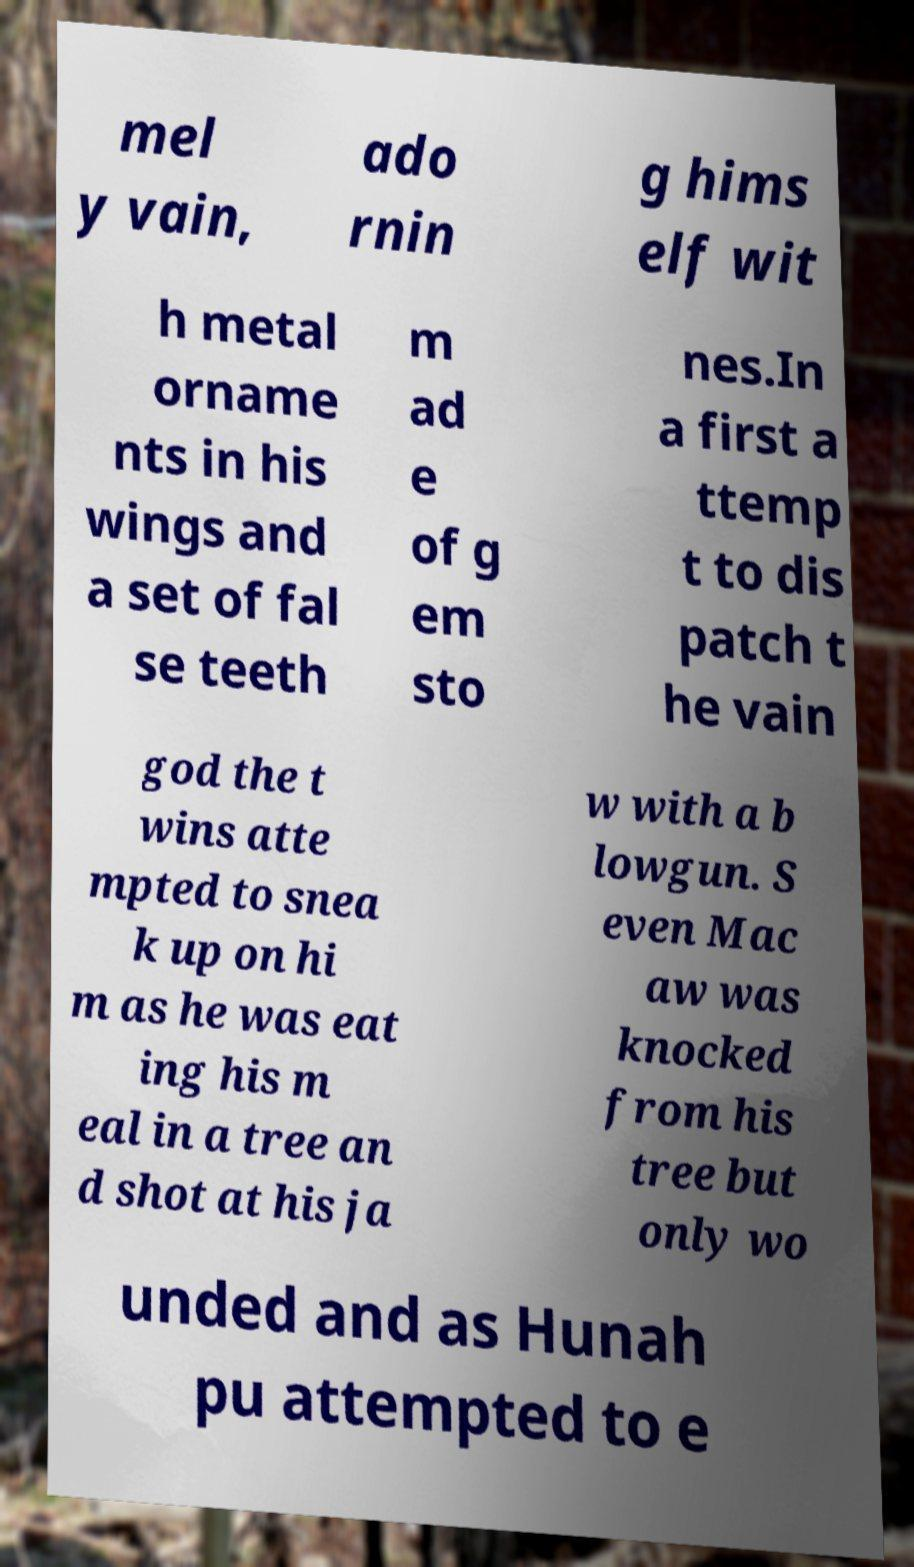Please identify and transcribe the text found in this image. mel y vain, ado rnin g hims elf wit h metal orname nts in his wings and a set of fal se teeth m ad e of g em sto nes.In a first a ttemp t to dis patch t he vain god the t wins atte mpted to snea k up on hi m as he was eat ing his m eal in a tree an d shot at his ja w with a b lowgun. S even Mac aw was knocked from his tree but only wo unded and as Hunah pu attempted to e 